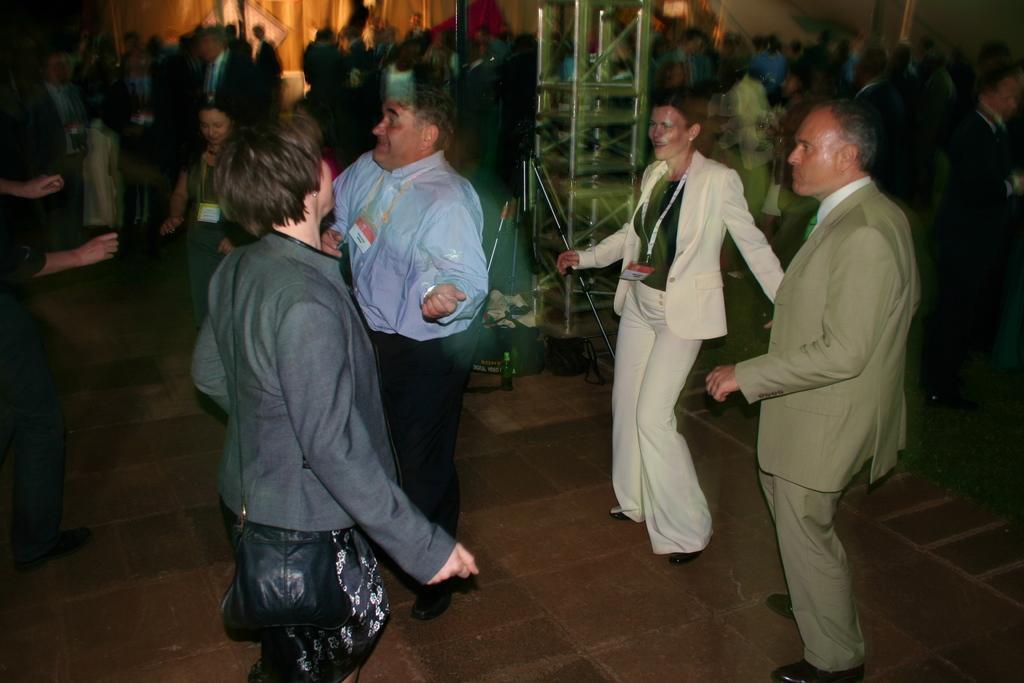Can you describe this image briefly? In this image we can able to see some persons dancing on the floor, there is a lady wearing a bag and we can able to see a bottle and bag on the floor, in the middle of the picture there is a pillar, and few persons are wearing access cards. 